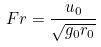Convert formula to latex. <formula><loc_0><loc_0><loc_500><loc_500>F r = \frac { u _ { 0 } } { \sqrt { g _ { 0 } r _ { 0 } } }</formula> 